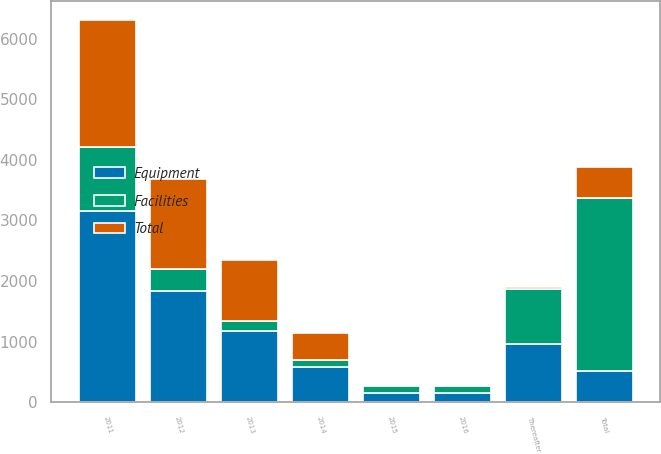Convert chart to OTSL. <chart><loc_0><loc_0><loc_500><loc_500><stacked_bar_chart><ecel><fcel>2011<fcel>2012<fcel>2013<fcel>2014<fcel>2015<fcel>2016<fcel>Thereafter<fcel>Total<nl><fcel>Facilities<fcel>1060<fcel>354<fcel>162<fcel>122<fcel>122<fcel>122<fcel>911<fcel>2853<nl><fcel>Total<fcel>2092<fcel>1484<fcel>1013<fcel>450<fcel>23<fcel>23<fcel>41<fcel>511<nl><fcel>Equipment<fcel>3152<fcel>1838<fcel>1175<fcel>572<fcel>145<fcel>145<fcel>952<fcel>511<nl></chart> 